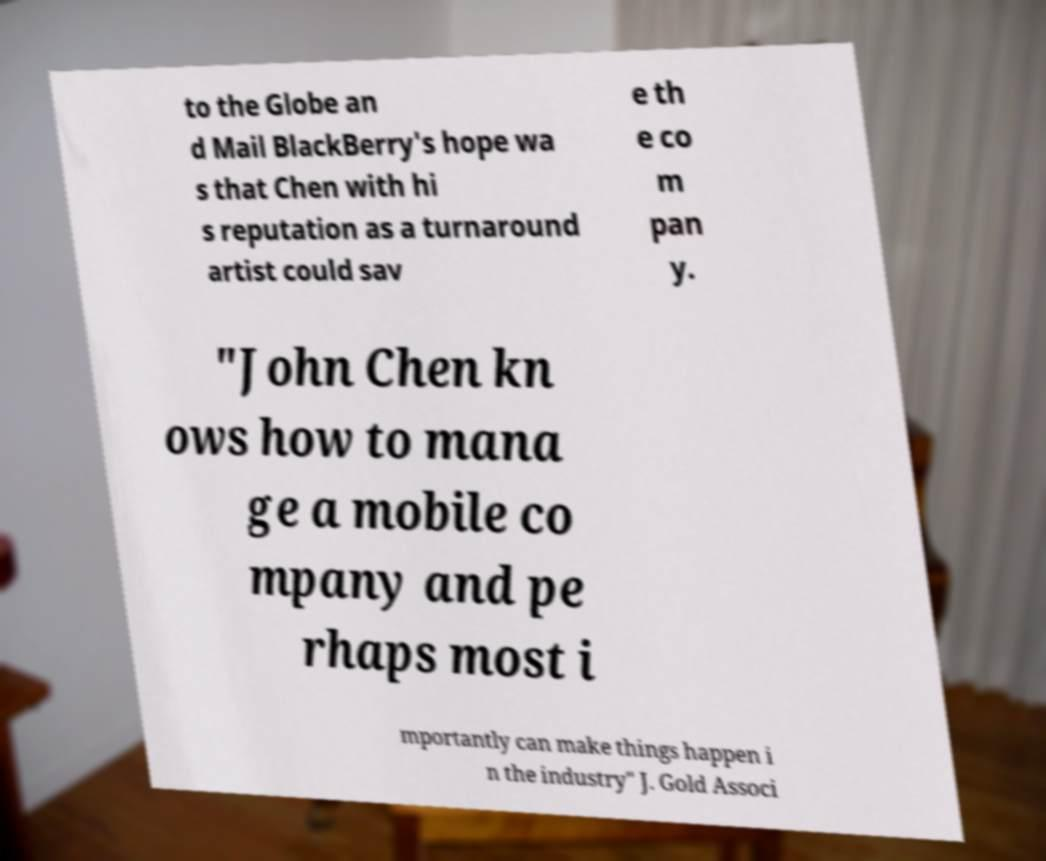Please read and relay the text visible in this image. What does it say? to the Globe an d Mail BlackBerry's hope wa s that Chen with hi s reputation as a turnaround artist could sav e th e co m pan y. "John Chen kn ows how to mana ge a mobile co mpany and pe rhaps most i mportantly can make things happen i n the industry" J. Gold Associ 